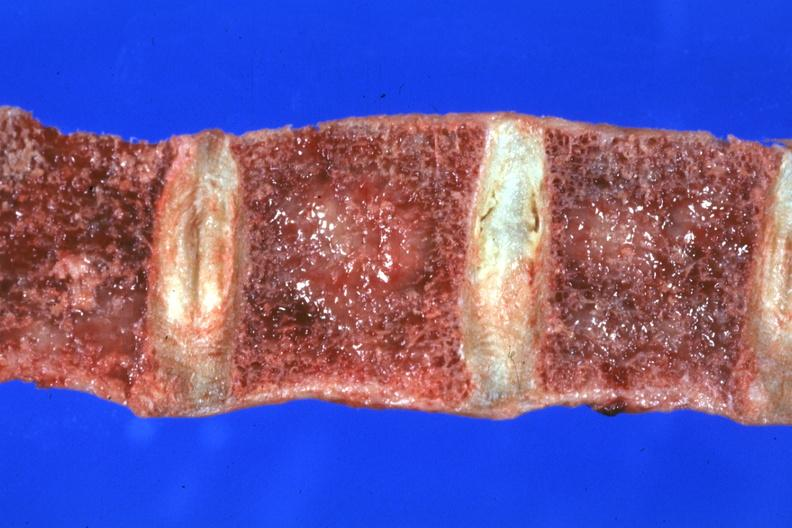does this image show close-up view of frontal section vertebral bodies excellent?
Answer the question using a single word or phrase. Yes 